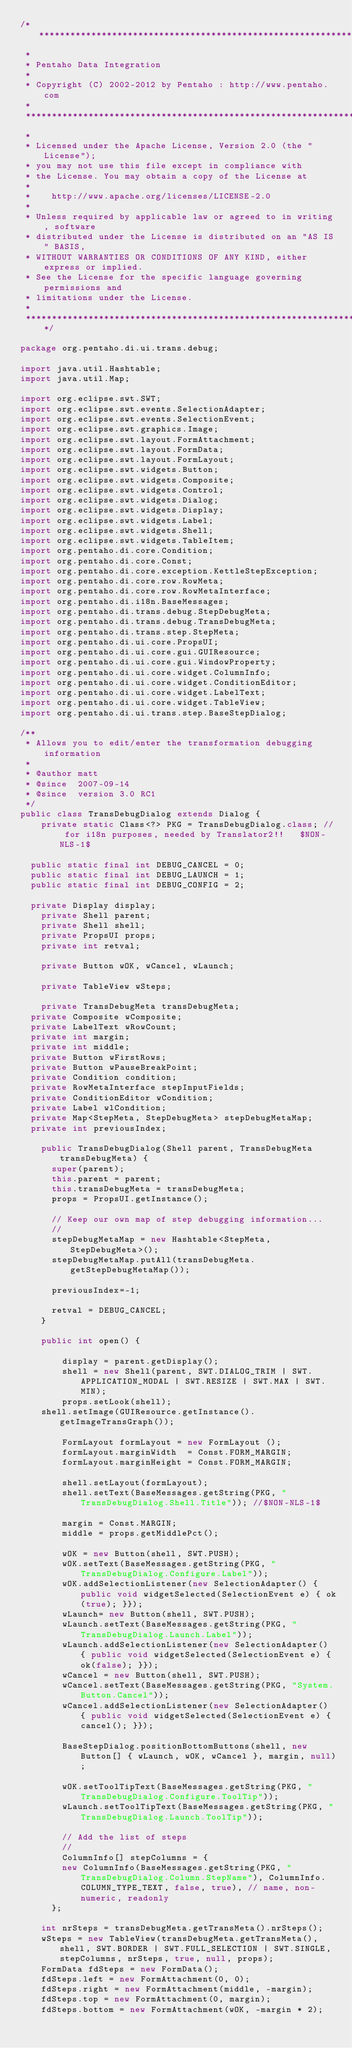Convert code to text. <code><loc_0><loc_0><loc_500><loc_500><_Java_>/*******************************************************************************
 *
 * Pentaho Data Integration
 *
 * Copyright (C) 2002-2012 by Pentaho : http://www.pentaho.com
 *
 *******************************************************************************
 *
 * Licensed under the Apache License, Version 2.0 (the "License");
 * you may not use this file except in compliance with
 * the License. You may obtain a copy of the License at
 *
 *    http://www.apache.org/licenses/LICENSE-2.0
 *
 * Unless required by applicable law or agreed to in writing, software
 * distributed under the License is distributed on an "AS IS" BASIS,
 * WITHOUT WARRANTIES OR CONDITIONS OF ANY KIND, either express or implied.
 * See the License for the specific language governing permissions and
 * limitations under the License.
 *
 ******************************************************************************/

package org.pentaho.di.ui.trans.debug;

import java.util.Hashtable;
import java.util.Map;

import org.eclipse.swt.SWT;
import org.eclipse.swt.events.SelectionAdapter;
import org.eclipse.swt.events.SelectionEvent;
import org.eclipse.swt.graphics.Image;
import org.eclipse.swt.layout.FormAttachment;
import org.eclipse.swt.layout.FormData;
import org.eclipse.swt.layout.FormLayout;
import org.eclipse.swt.widgets.Button;
import org.eclipse.swt.widgets.Composite;
import org.eclipse.swt.widgets.Control;
import org.eclipse.swt.widgets.Dialog;
import org.eclipse.swt.widgets.Display;
import org.eclipse.swt.widgets.Label;
import org.eclipse.swt.widgets.Shell;
import org.eclipse.swt.widgets.TableItem;
import org.pentaho.di.core.Condition;
import org.pentaho.di.core.Const;
import org.pentaho.di.core.exception.KettleStepException;
import org.pentaho.di.core.row.RowMeta;
import org.pentaho.di.core.row.RowMetaInterface;
import org.pentaho.di.i18n.BaseMessages;
import org.pentaho.di.trans.debug.StepDebugMeta;
import org.pentaho.di.trans.debug.TransDebugMeta;
import org.pentaho.di.trans.step.StepMeta;
import org.pentaho.di.ui.core.PropsUI;
import org.pentaho.di.ui.core.gui.GUIResource;
import org.pentaho.di.ui.core.gui.WindowProperty;
import org.pentaho.di.ui.core.widget.ColumnInfo;
import org.pentaho.di.ui.core.widget.ConditionEditor;
import org.pentaho.di.ui.core.widget.LabelText;
import org.pentaho.di.ui.core.widget.TableView;
import org.pentaho.di.ui.trans.step.BaseStepDialog;

/**
 * Allows you to edit/enter the transformation debugging information 
 * 
 * @author matt
 * @since  2007-09-14
 * @since  version 3.0 RC1
 */
public class TransDebugDialog extends Dialog {
    private static Class<?> PKG = TransDebugDialog.class; // for i18n purposes, needed by Translator2!!   $NON-NLS-1$

	public static final int DEBUG_CANCEL = 0;
	public static final int DEBUG_LAUNCH = 1;
	public static final int DEBUG_CONFIG = 2;
	
	private Display display;
    private Shell parent;
    private Shell shell;
    private PropsUI props;
    private int retval;

    private Button wOK, wCancel, wLaunch;
    
    private TableView wSteps;
    
    private TransDebugMeta transDebugMeta;
	private Composite wComposite;
	private LabelText wRowCount;
	private int margin;
	private int middle;
	private Button wFirstRows;
	private Button wPauseBreakPoint;
	private Condition condition;
	private RowMetaInterface stepInputFields;
	private ConditionEditor wCondition;
	private Label wlCondition;
	private Map<StepMeta, StepDebugMeta> stepDebugMetaMap;
	private int previousIndex; 
    
    public TransDebugDialog(Shell parent, TransDebugMeta transDebugMeta) {
    	super(parent);
    	this.parent = parent;
    	this.transDebugMeta = transDebugMeta;
    	props = PropsUI.getInstance();
    	
    	// Keep our own map of step debugging information...
    	//
    	stepDebugMetaMap = new Hashtable<StepMeta, StepDebugMeta>();
    	stepDebugMetaMap.putAll(transDebugMeta.getStepDebugMetaMap());
    	
    	previousIndex=-1;
    	
    	retval = DEBUG_CANCEL;
    }
 
    public int open() {
    	
        display = parent.getDisplay();
        shell = new Shell(parent, SWT.DIALOG_TRIM | SWT.APPLICATION_MODAL | SWT.RESIZE | SWT.MAX | SWT.MIN);
        props.setLook(shell);
		shell.setImage(GUIResource.getInstance().getImageTransGraph());
        
        FormLayout formLayout = new FormLayout ();
        formLayout.marginWidth  = Const.FORM_MARGIN;
        formLayout.marginHeight = Const.FORM_MARGIN;

        shell.setLayout(formLayout);
        shell.setText(BaseMessages.getString(PKG, "TransDebugDialog.Shell.Title")); //$NON-NLS-1$

        margin = Const.MARGIN;
        middle = props.getMiddlePct();
        
        wOK = new Button(shell, SWT.PUSH);
        wOK.setText(BaseMessages.getString(PKG, "TransDebugDialog.Configure.Label"));
        wOK.addSelectionListener(new SelectionAdapter() { public void widgetSelected(SelectionEvent e) { ok(true); }});
        wLaunch= new Button(shell, SWT.PUSH);
        wLaunch.setText(BaseMessages.getString(PKG, "TransDebugDialog.Launch.Label"));
        wLaunch.addSelectionListener(new SelectionAdapter() { public void widgetSelected(SelectionEvent e) { ok(false); }});
        wCancel = new Button(shell, SWT.PUSH);
        wCancel.setText(BaseMessages.getString(PKG, "System.Button.Cancel"));
        wCancel.addSelectionListener(new SelectionAdapter() { public void widgetSelected(SelectionEvent e) { cancel(); }});
        
        BaseStepDialog.positionBottomButtons(shell, new Button[] { wLaunch, wOK, wCancel }, margin, null);
    	
        wOK.setToolTipText(BaseMessages.getString(PKG, "TransDebugDialog.Configure.ToolTip"));
        wLaunch.setToolTipText(BaseMessages.getString(PKG, "TransDebugDialog.Launch.ToolTip"));
        
        // Add the list of steps
        //
        ColumnInfo[] stepColumns = {
				new ColumnInfo(BaseMessages.getString(PKG, "TransDebugDialog.Column.StepName"), ColumnInfo.COLUMN_TYPE_TEXT, false, true), // name, non-numeric, readonly
			};

		int nrSteps = transDebugMeta.getTransMeta().nrSteps();
		wSteps = new TableView(transDebugMeta.getTransMeta(), shell, SWT.BORDER | SWT.FULL_SELECTION | SWT.SINGLE, stepColumns, nrSteps, true, null, props);
		FormData fdSteps = new FormData();
		fdSteps.left = new FormAttachment(0, 0);
		fdSteps.right = new FormAttachment(middle, -margin);
		fdSteps.top = new FormAttachment(0, margin);
		fdSteps.bottom = new FormAttachment(wOK, -margin * 2);</code> 